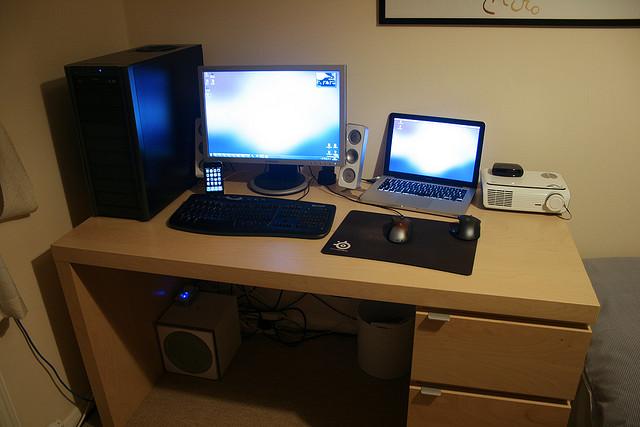What color is the wastebasket?
Short answer required. White. Where is the board?
Answer briefly. Desk. Are the computers on?
Be succinct. Yes. What is to the left?
Quick response, please. Computer. Same work is going on in both laptop?
Concise answer only. Yes. How many lights are lit on the desktop CPU?
Write a very short answer. 1. How many mice do you see?
Answer briefly. 2. What brand is the mouse pad?
Quick response, please. Dell. 